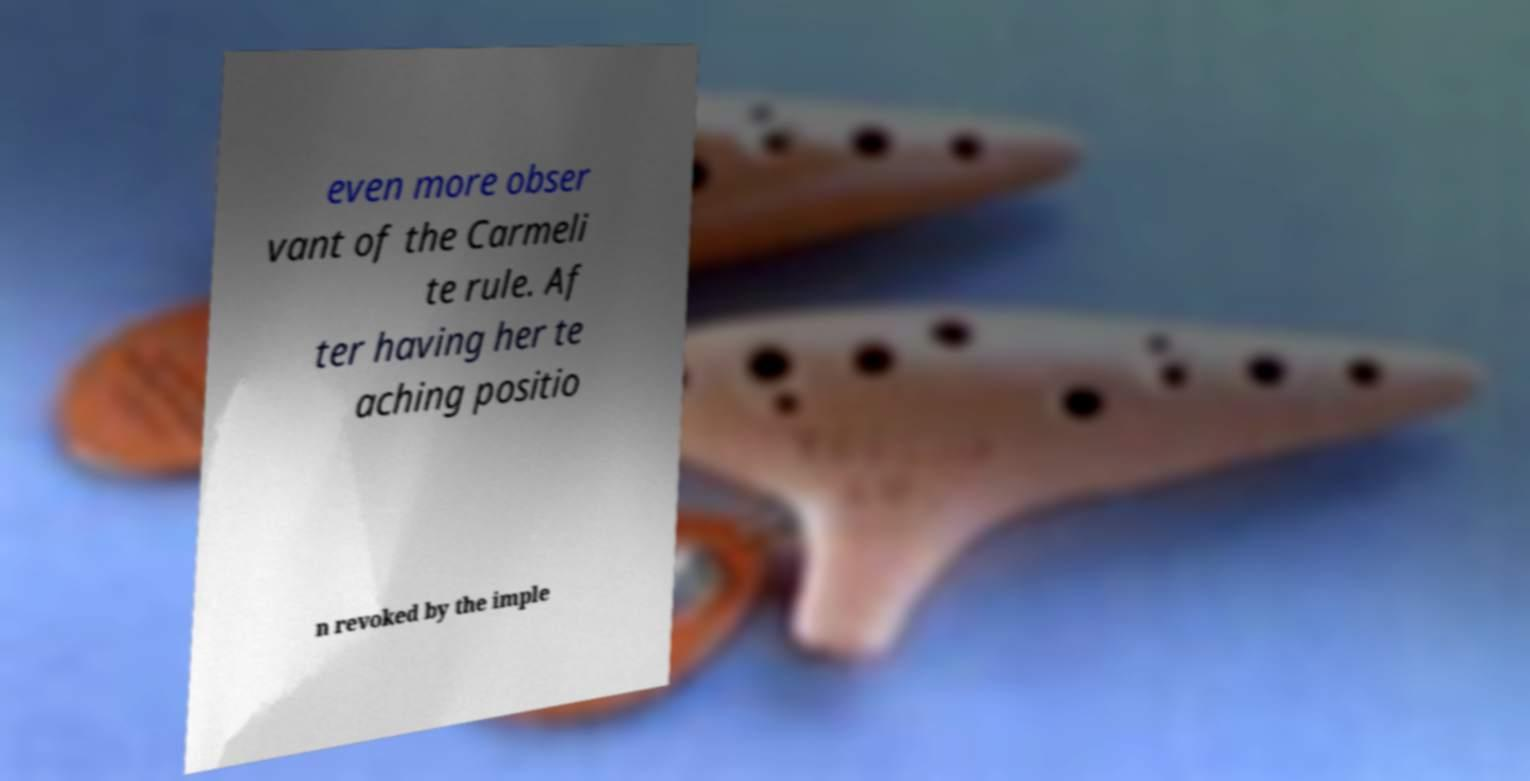Could you extract and type out the text from this image? even more obser vant of the Carmeli te rule. Af ter having her te aching positio n revoked by the imple 